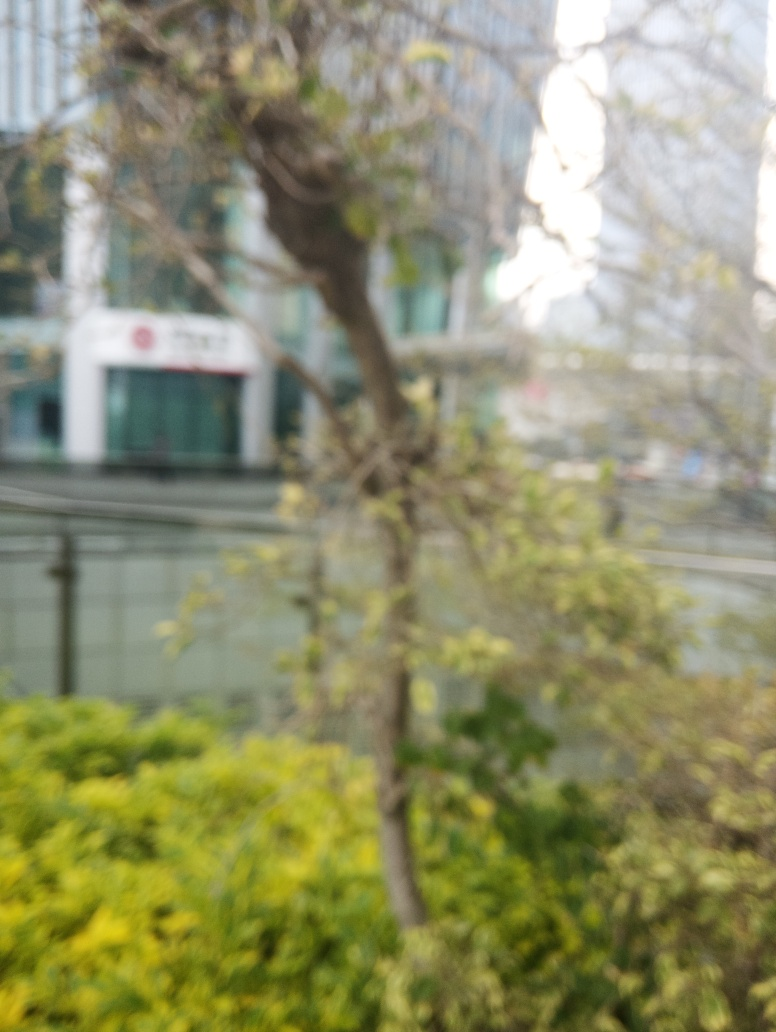What kind of setting does this image depict? The image displays an urban environment with a blurry foreground of natural elements, such as a tree and some shrubbery, contrasted against what appears to be a backdrop of modern buildings, possibly offices or residential apartments. Is it possible to identify the type of tree or plants? Unfortunately, due to the focus issue in the image, it's quite challenging to precisely identify the species of the tree or plants. However, the overall shape of the tree, with its seemingly sparse foliage, suggests it could be in a state of transition, either at the onset of a new season or undergoing environmental stress. 